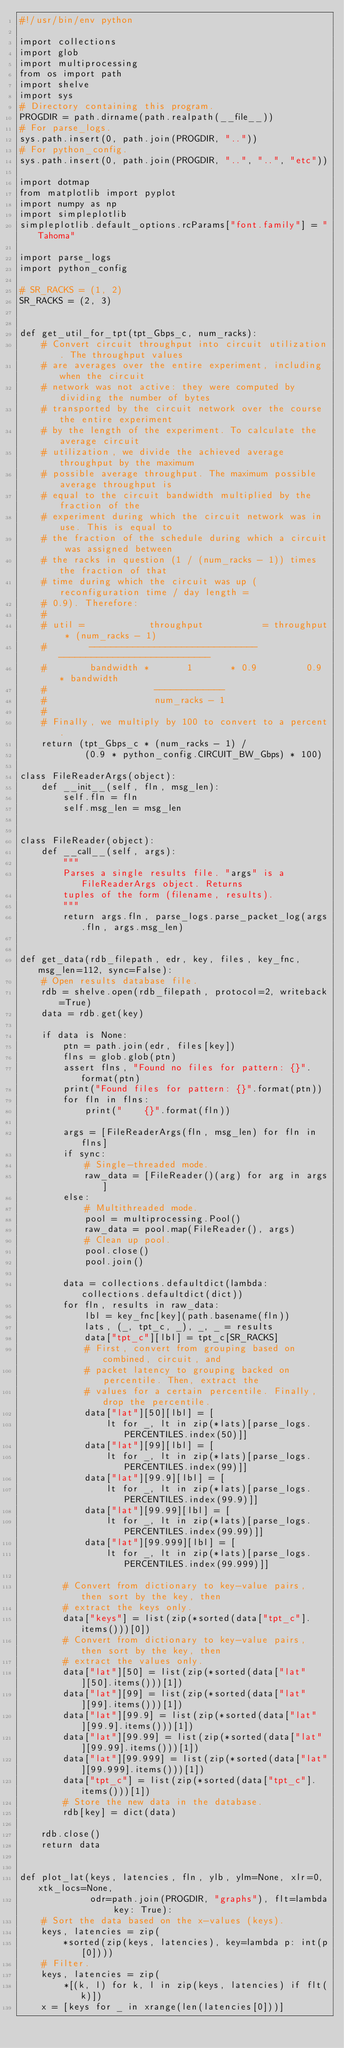Convert code to text. <code><loc_0><loc_0><loc_500><loc_500><_Python_>#!/usr/bin/env python

import collections
import glob
import multiprocessing
from os import path
import shelve
import sys
# Directory containing this program.
PROGDIR = path.dirname(path.realpath(__file__))
# For parse_logs.
sys.path.insert(0, path.join(PROGDIR, ".."))
# For python_config.
sys.path.insert(0, path.join(PROGDIR, "..", "..", "etc"))

import dotmap
from matplotlib import pyplot
import numpy as np
import simpleplotlib
simpleplotlib.default_options.rcParams["font.family"] = "Tahoma"

import parse_logs
import python_config

# SR_RACKS = (1, 2)
SR_RACKS = (2, 3)


def get_util_for_tpt(tpt_Gbps_c, num_racks):
    # Convert circuit throughput into circuit utilization. The throughput values
    # are averages over the entire experiment, including when the circuit
    # network was not active: they were computed by dividing the number of bytes
    # transported by the circuit network over the course the entire experiment
    # by the length of the experiment. To calculate the average circuit
    # utilization, we divide the achieved average throughput by the maximum
    # possible average throughput. The maximum possible average throughput is
    # equal to the circuit bandwidth multiplied by the fraction of the
    # experiment during which the circuit network was in use. This is equal to
    # the fraction of the schedule during which a circuit was assigned between
    # the racks in question (1 / (num_racks - 1)) times the fraction of that
    # time during which the circuit was up (reconfiguration time / day length =
    # 0.9). Therefore:
    #
    # util =            throughput           = throughput * (num_racks - 1)
    #        -------------------------------   ----------------------------
    #        bandwidth *       1       * 0.9         0.9 * bandwidth
    #                    -------------
    #                    num_racks - 1
    #
    # Finally, we multiply by 100 to convert to a percent.
    return (tpt_Gbps_c * (num_racks - 1) /
            (0.9 * python_config.CIRCUIT_BW_Gbps) * 100)

class FileReaderArgs(object):
    def __init__(self, fln, msg_len):
        self.fln = fln
        self.msg_len = msg_len


class FileReader(object):
    def __call__(self, args):
        """
        Parses a single results file. "args" is a FileReaderArgs object. Returns
        tuples of the form (filename, results).
        """
        return args.fln, parse_logs.parse_packet_log(args.fln, args.msg_len)


def get_data(rdb_filepath, edr, key, files, key_fnc, msg_len=112, sync=False):
    # Open results database file.
    rdb = shelve.open(rdb_filepath, protocol=2, writeback=True)
    data = rdb.get(key)

    if data is None:
        ptn = path.join(edr, files[key])
        flns = glob.glob(ptn)
        assert flns, "Found no files for pattern: {}".format(ptn)
        print("Found files for pattern: {}".format(ptn))
        for fln in flns:
            print("    {}".format(fln))

        args = [FileReaderArgs(fln, msg_len) for fln in flns]
        if sync:
            # Single-threaded mode.
            raw_data = [FileReader()(arg) for arg in args]
        else:
            # Multithreaded mode.
            pool = multiprocessing.Pool()
            raw_data = pool.map(FileReader(), args)
            # Clean up pool.
            pool.close()
            pool.join()

        data = collections.defaultdict(lambda: collections.defaultdict(dict))
        for fln, results in raw_data:
            lbl = key_fnc[key](path.basename(fln))
            lats, (_, tpt_c, _), _, _ = results
            data["tpt_c"][lbl] = tpt_c[SR_RACKS]
            # First, convert from grouping based on combined, circuit, and
            # packet latency to grouping backed on percentile. Then, extract the
            # values for a certain percentile. Finally, drop the percentile.
            data["lat"][50][lbl] = [
                lt for _, lt in zip(*lats)[parse_logs.PERCENTILES.index(50)]]
            data["lat"][99][lbl] = [
                lt for _, lt in zip(*lats)[parse_logs.PERCENTILES.index(99)]]
            data["lat"][99.9][lbl] = [
                lt for _, lt in zip(*lats)[parse_logs.PERCENTILES.index(99.9)]]
            data["lat"][99.99][lbl] = [
                lt for _, lt in zip(*lats)[parse_logs.PERCENTILES.index(99.99)]]
            data["lat"][99.999][lbl] = [
                lt for _, lt in zip(*lats)[parse_logs.PERCENTILES.index(99.999)]]

        # Convert from dictionary to key-value pairs, then sort by the key, then
        # extract the keys only.
        data["keys"] = list(zip(*sorted(data["tpt_c"].items()))[0])
        # Convert from dictionary to key-value pairs, then sort by the key, then
        # extract the values only.
        data["lat"][50] = list(zip(*sorted(data["lat"][50].items()))[1])
        data["lat"][99] = list(zip(*sorted(data["lat"][99].items()))[1])
        data["lat"][99.9] = list(zip(*sorted(data["lat"][99.9].items()))[1])
        data["lat"][99.99] = list(zip(*sorted(data["lat"][99.99].items()))[1])
        data["lat"][99.999] = list(zip(*sorted(data["lat"][99.999].items()))[1])
        data["tpt_c"] = list(zip(*sorted(data["tpt_c"].items()))[1])
        # Store the new data in the database.
        rdb[key] = dict(data)

    rdb.close()
    return data


def plot_lat(keys, latencies, fln, ylb, ylm=None, xlr=0, xtk_locs=None,
             odr=path.join(PROGDIR, "graphs"), flt=lambda key: True):
    # Sort the data based on the x-values (keys).
    keys, latencies = zip(
        *sorted(zip(keys, latencies), key=lambda p: int(p[0])))
    # Filter.
    keys, latencies = zip(
        *[(k, l) for k, l in zip(keys, latencies) if flt(k)])
    x = [keys for _ in xrange(len(latencies[0]))]</code> 